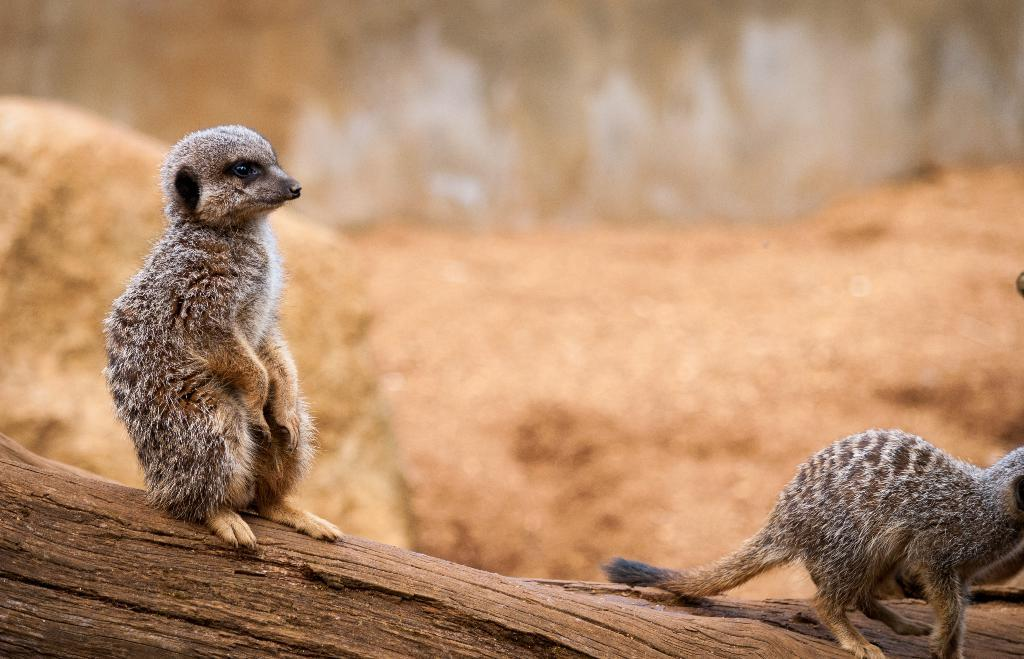What is at the bottom of the image? There is a tree trunk at the bottom of the image. What animals are on the tree trunk? There are two meerkats on the tree trunk. How would you describe the background of the image? The background of the image is blurred and black. What type of apparel is the beggar wearing in the image? There is no beggar present in the image, so it is not possible to determine what type of apparel they might be wearing. 